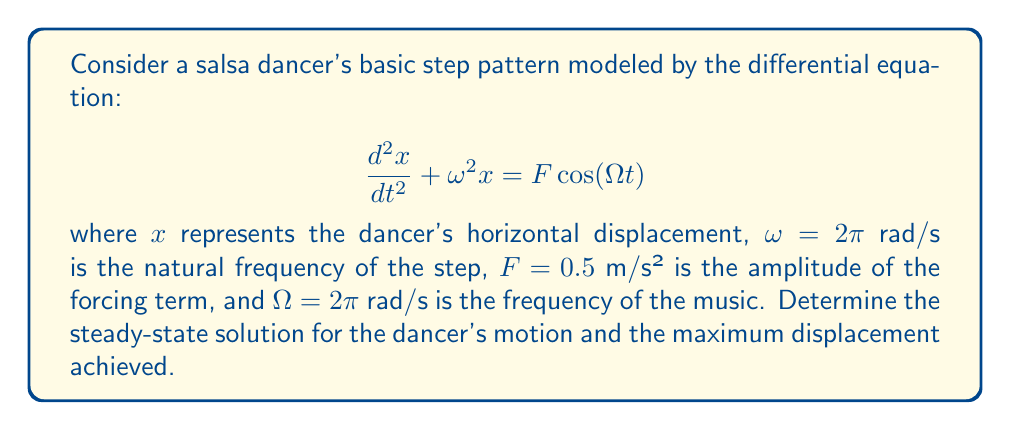Help me with this question. 1) The given equation is a forced harmonic oscillator. For the steady-state solution, we assume:

   $$x(t) = A\cos(\Omega t) + B\sin(\Omega t)$$

2) Substitute this into the original equation:

   $$-A\Omega^2\cos(\Omega t) - B\Omega^2\sin(\Omega t) + \omega^2(A\cos(\Omega t) + B\sin(\Omega t)) = F\cos(\Omega t)$$

3) Equate coefficients:

   $$(\omega^2 - \Omega^2)A = F$$
   $$(\omega^2 - \Omega^2)B = 0$$

4) Solve for A and B:

   $$A = \frac{F}{\omega^2 - \Omega^2} = \frac{0.5}{(2\pi)^2 - (2\pi)^2} = \infty$$
   $$B = 0$$

5) This result indicates resonance, as $\omega = \Omega$. In practice, there would be damping, preventing infinite amplitude.

6) To find a realistic solution, we introduce a small damping term $2\zeta\omega\frac{dx}{dt}$ with $\zeta = 0.1$:

   $$\frac{d^2x}{dt^2} + 2\zeta\omega\frac{dx}{dt} + \omega^2x = F\cos(\Omega t)$$

7) The steady-state solution for this damped system is:

   $$x(t) = \frac{F}{\sqrt{(\omega^2 - \Omega^2)^2 + (2\zeta\omega\Omega)^2}}\cos(\Omega t - \phi)$$

   where $\phi = \tan^{-1}(\frac{2\zeta\omega\Omega}{\omega^2 - \Omega^2})$

8) Substituting the values:

   $$x(t) = \frac{0.5}{\sqrt{0^2 + (2 \cdot 0.1 \cdot 2\pi \cdot 2\pi)^2}}\cos(2\pi t - \frac{\pi}{2})$$

9) Simplify:

   $$x(t) = \frac{0.5}{0.8\pi}\sin(2\pi t) \approx 0.1989\sin(2\pi t)$$

10) The maximum displacement is the amplitude of this sinusoidal motion: approximately 0.1989 meters.
Answer: $x(t) \approx 0.1989\sin(2\pi t)$ meters; max displacement ≈ 0.1989 m 